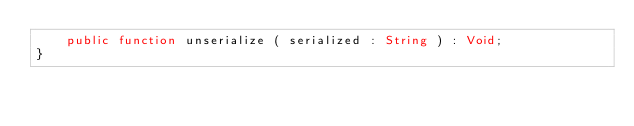<code> <loc_0><loc_0><loc_500><loc_500><_Haxe_>    public function unserialize ( serialized : String ) : Void;
}
</code> 